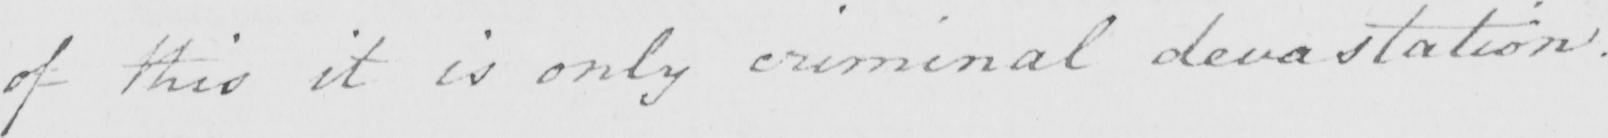Please transcribe the handwritten text in this image. of this it is only criminal devastation . 